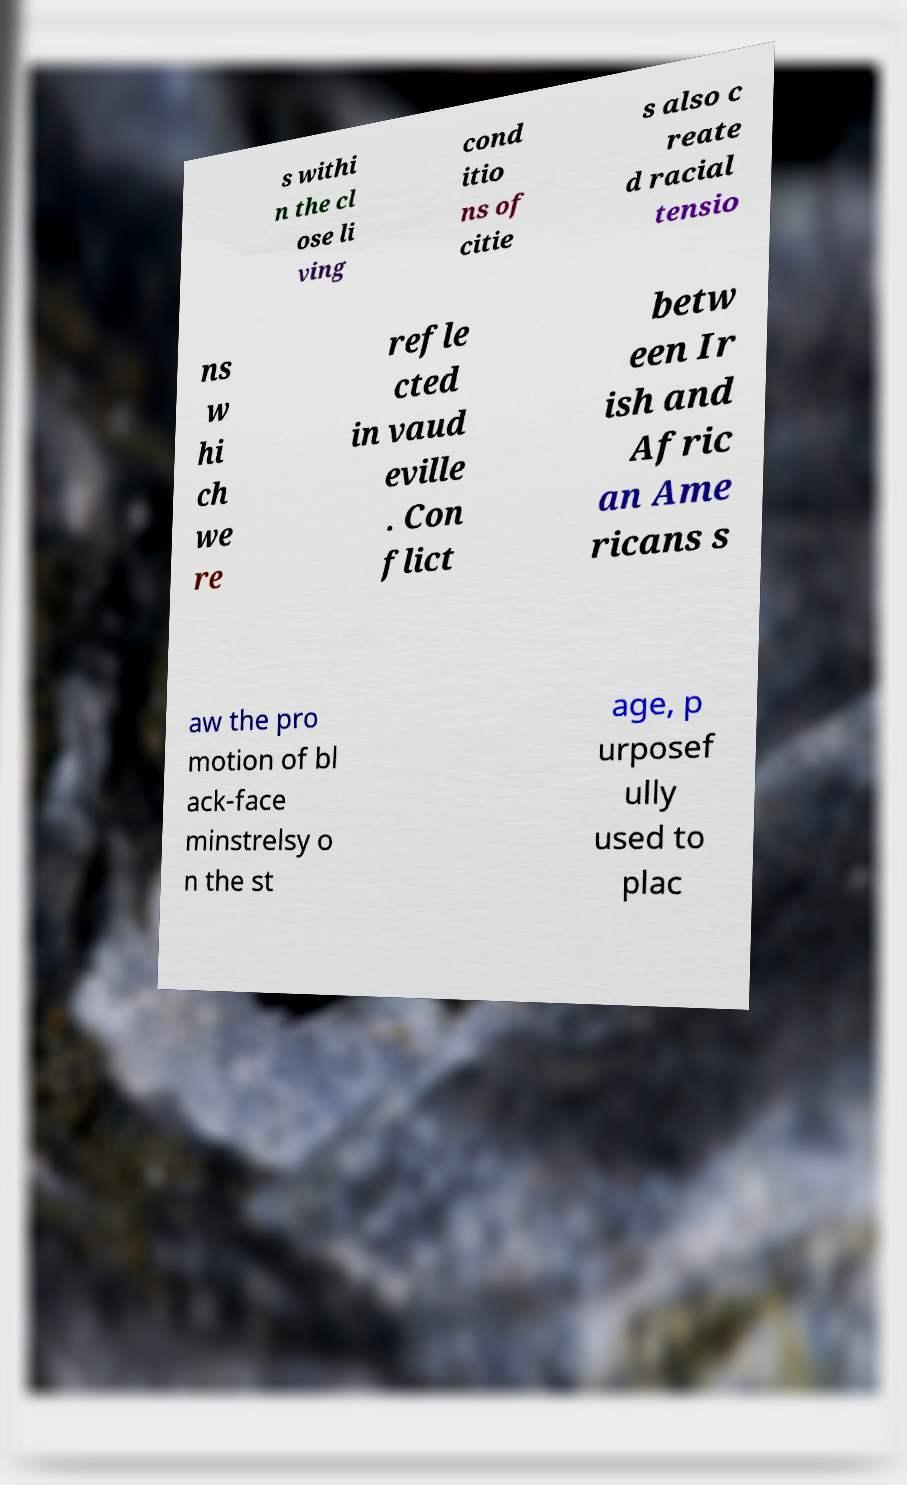What messages or text are displayed in this image? I need them in a readable, typed format. s withi n the cl ose li ving cond itio ns of citie s also c reate d racial tensio ns w hi ch we re refle cted in vaud eville . Con flict betw een Ir ish and Afric an Ame ricans s aw the pro motion of bl ack-face minstrelsy o n the st age, p urposef ully used to plac 